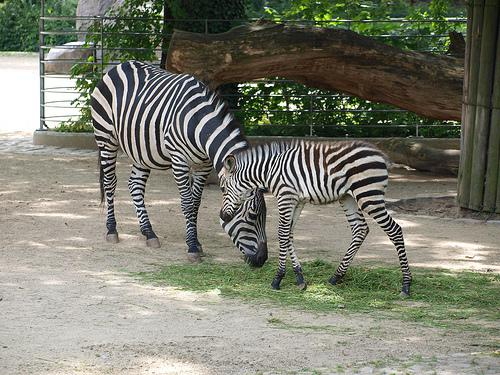Question: what species of animal is shown?
Choices:
A. Rhinoceros.
B. Zebra.
C. Comodo dragon.
D. Platypus.
Answer with the letter. Answer: B Question: how many zebras are there?
Choices:
A. Three.
B. Two.
C. Four.
D. Five.
Answer with the letter. Answer: B Question: what prevents the zebras from being free?
Choices:
A. The fence.
B. Wall.
C. Moat.
D. Barricades.
Answer with the letter. Answer: A Question: what color are the hooves of the zebra to the left in the image?
Choices:
A. White.
B. Black.
C. Red.
D. Dirty brown.
Answer with the letter. Answer: A 